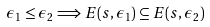Convert formula to latex. <formula><loc_0><loc_0><loc_500><loc_500>\epsilon _ { 1 } \leq \epsilon _ { 2 } \Longrightarrow E ( s , \epsilon _ { 1 } ) \subseteq E ( s , \epsilon _ { 2 } )</formula> 